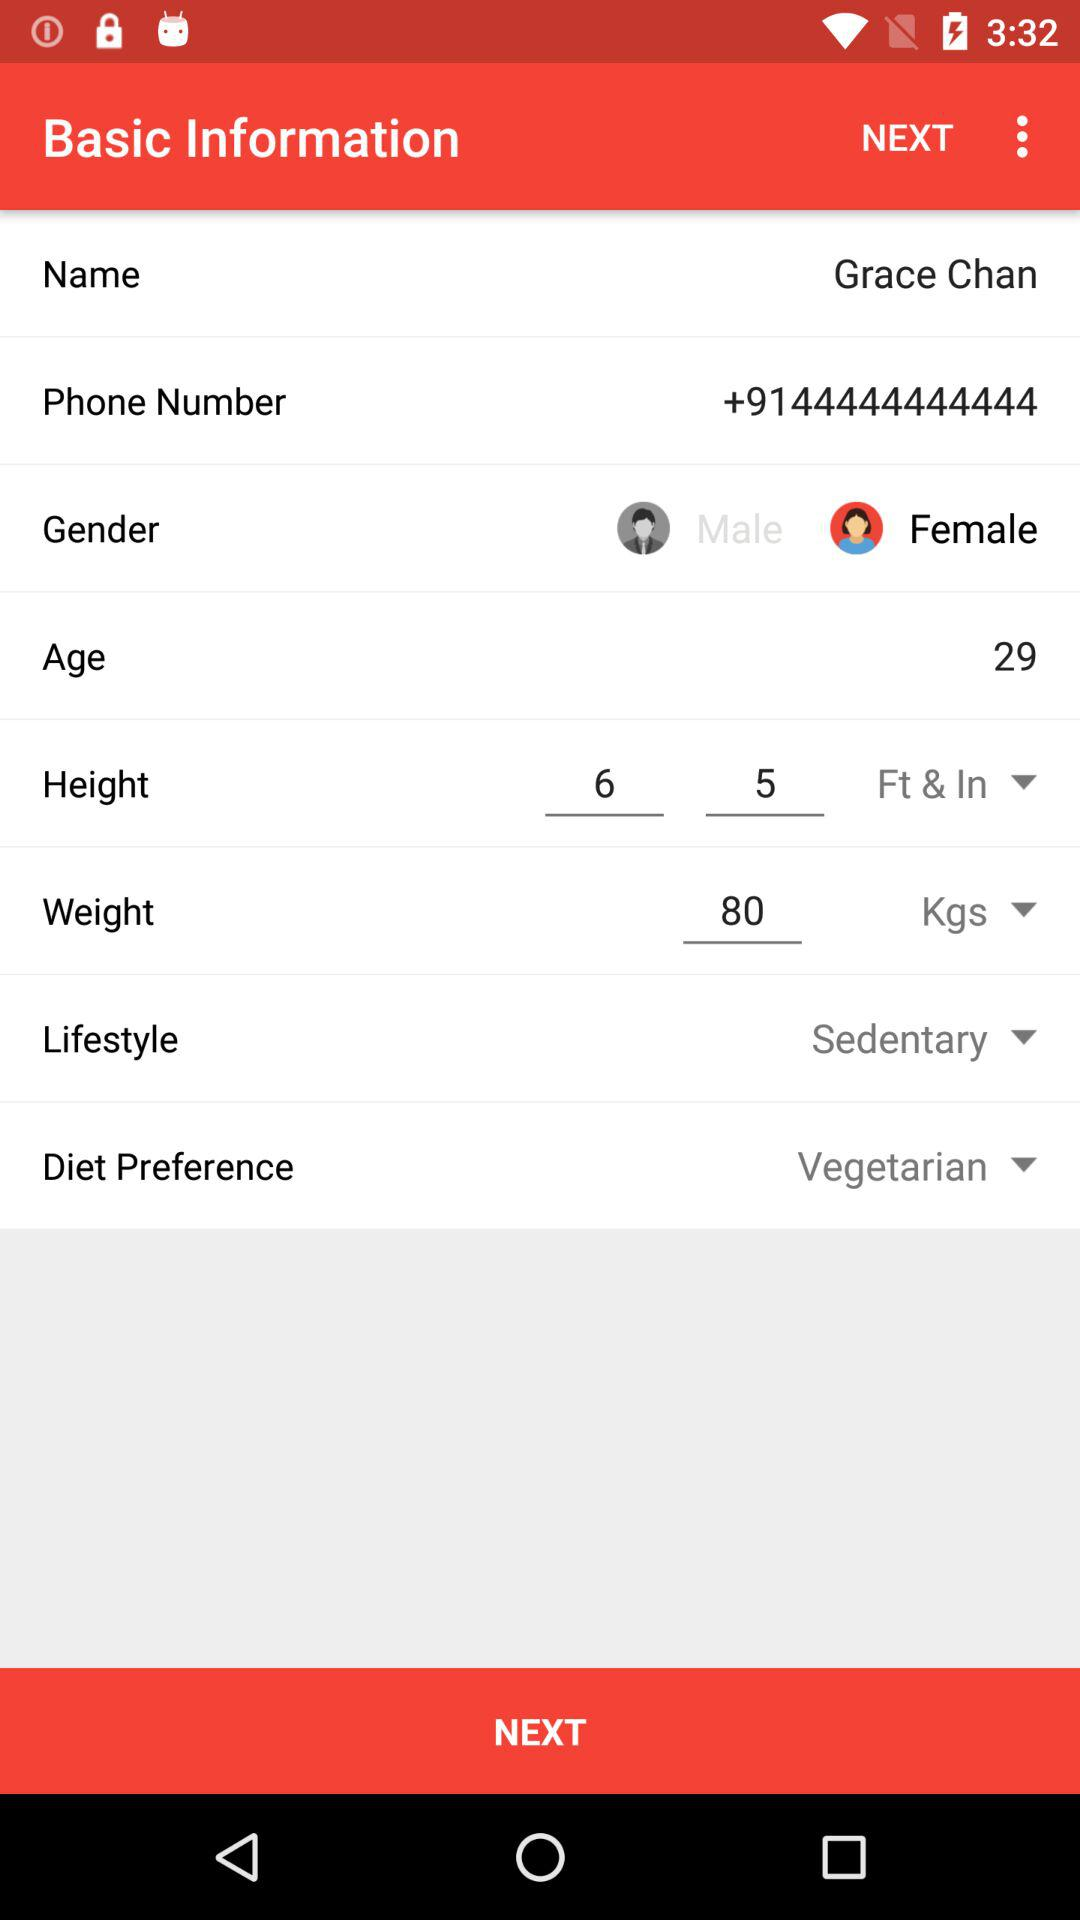What is Grace Chan's lifestyle?
Answer the question using a single word or phrase. Sedentary 